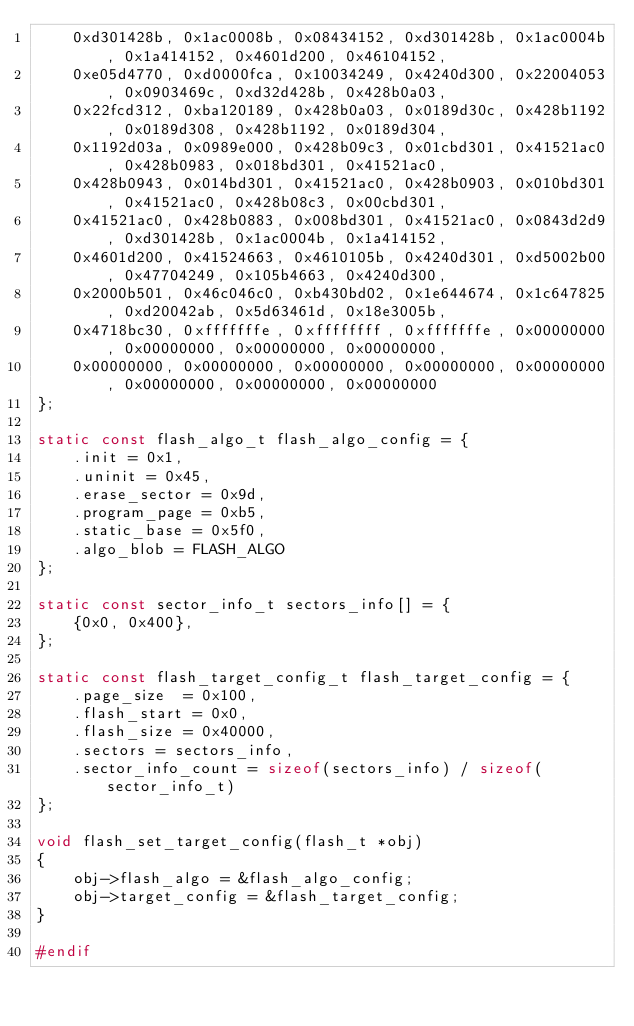<code> <loc_0><loc_0><loc_500><loc_500><_C_>    0xd301428b, 0x1ac0008b, 0x08434152, 0xd301428b, 0x1ac0004b, 0x1a414152, 0x4601d200, 0x46104152,
    0xe05d4770, 0xd0000fca, 0x10034249, 0x4240d300, 0x22004053, 0x0903469c, 0xd32d428b, 0x428b0a03,
    0x22fcd312, 0xba120189, 0x428b0a03, 0x0189d30c, 0x428b1192, 0x0189d308, 0x428b1192, 0x0189d304,
    0x1192d03a, 0x0989e000, 0x428b09c3, 0x01cbd301, 0x41521ac0, 0x428b0983, 0x018bd301, 0x41521ac0,
    0x428b0943, 0x014bd301, 0x41521ac0, 0x428b0903, 0x010bd301, 0x41521ac0, 0x428b08c3, 0x00cbd301,
    0x41521ac0, 0x428b0883, 0x008bd301, 0x41521ac0, 0x0843d2d9, 0xd301428b, 0x1ac0004b, 0x1a414152,
    0x4601d200, 0x41524663, 0x4610105b, 0x4240d301, 0xd5002b00, 0x47704249, 0x105b4663, 0x4240d300,
    0x2000b501, 0x46c046c0, 0xb430bd02, 0x1e644674, 0x1c647825, 0xd20042ab, 0x5d63461d, 0x18e3005b,
    0x4718bc30, 0xfffffffe, 0xffffffff, 0xfffffffe, 0x00000000, 0x00000000, 0x00000000, 0x00000000,
    0x00000000, 0x00000000, 0x00000000, 0x00000000, 0x00000000, 0x00000000, 0x00000000, 0x00000000
};

static const flash_algo_t flash_algo_config = {
    .init = 0x1,
    .uninit = 0x45,
    .erase_sector = 0x9d,
    .program_page = 0xb5,
    .static_base = 0x5f0,
    .algo_blob = FLASH_ALGO
};

static const sector_info_t sectors_info[] = {
    {0x0, 0x400},
};

static const flash_target_config_t flash_target_config = {
    .page_size  = 0x100,
    .flash_start = 0x0,
    .flash_size = 0x40000,
    .sectors = sectors_info,
    .sector_info_count = sizeof(sectors_info) / sizeof(sector_info_t)
};

void flash_set_target_config(flash_t *obj)
{
    obj->flash_algo = &flash_algo_config;
    obj->target_config = &flash_target_config;
}

#endif
</code> 